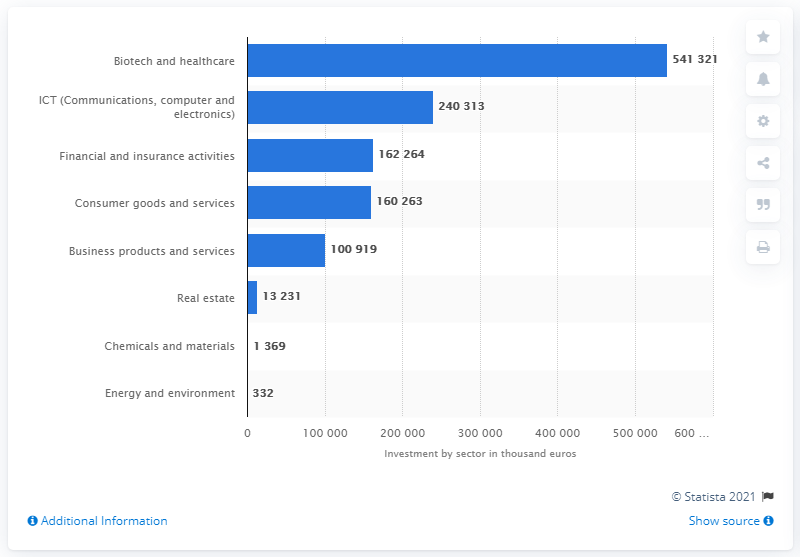Highlight a few significant elements in this photo. The average between financial and insurance activities and consumer goods and services is 161,263.5. The data is categorized as Real Estate. 